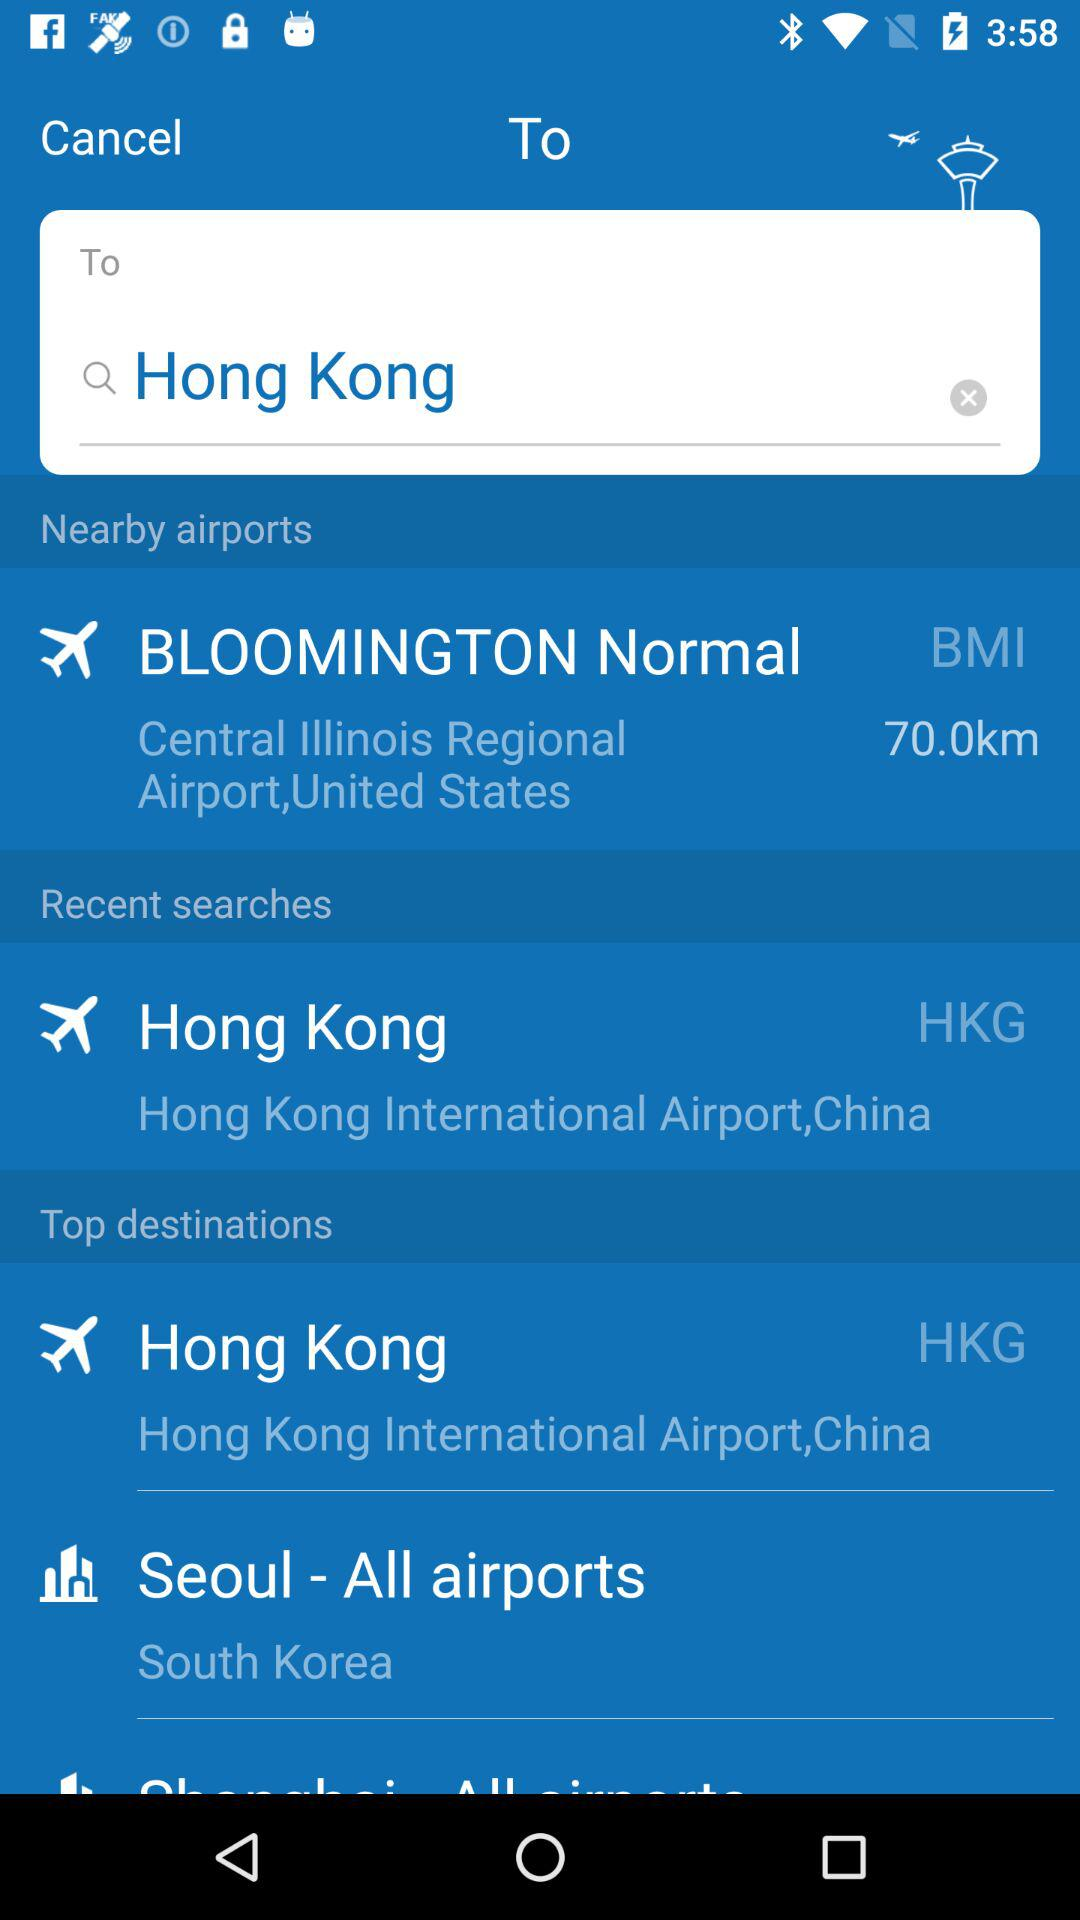What is the location of Hong Kong airport? The location is Hong Kong. 